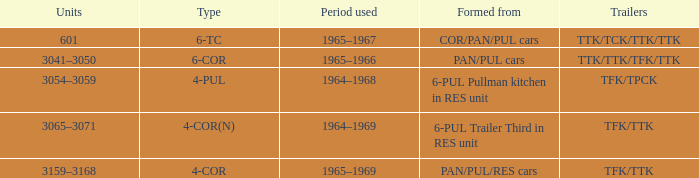Identify the shape that exhibits a 4-cornered structure. PAN/PUL/RES cars. 